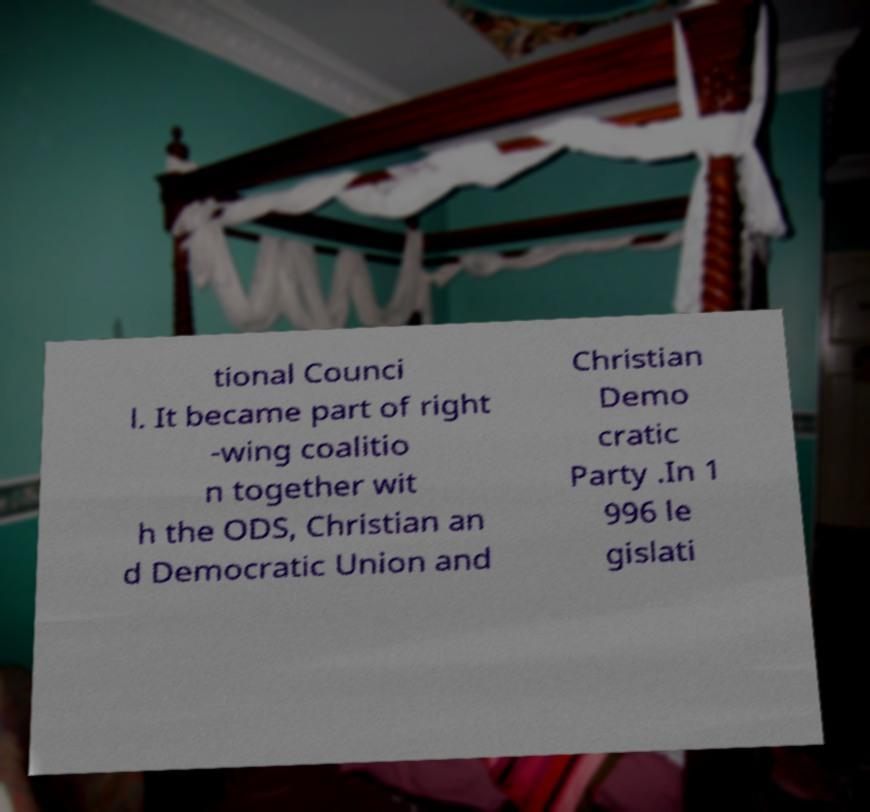Could you extract and type out the text from this image? tional Counci l. It became part of right -wing coalitio n together wit h the ODS, Christian an d Democratic Union and Christian Demo cratic Party .In 1 996 le gislati 